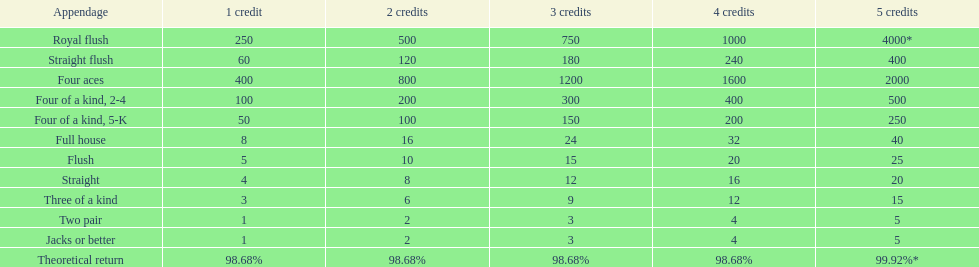What's the best type of four of a kind to win? Four of a kind, 2-4. 